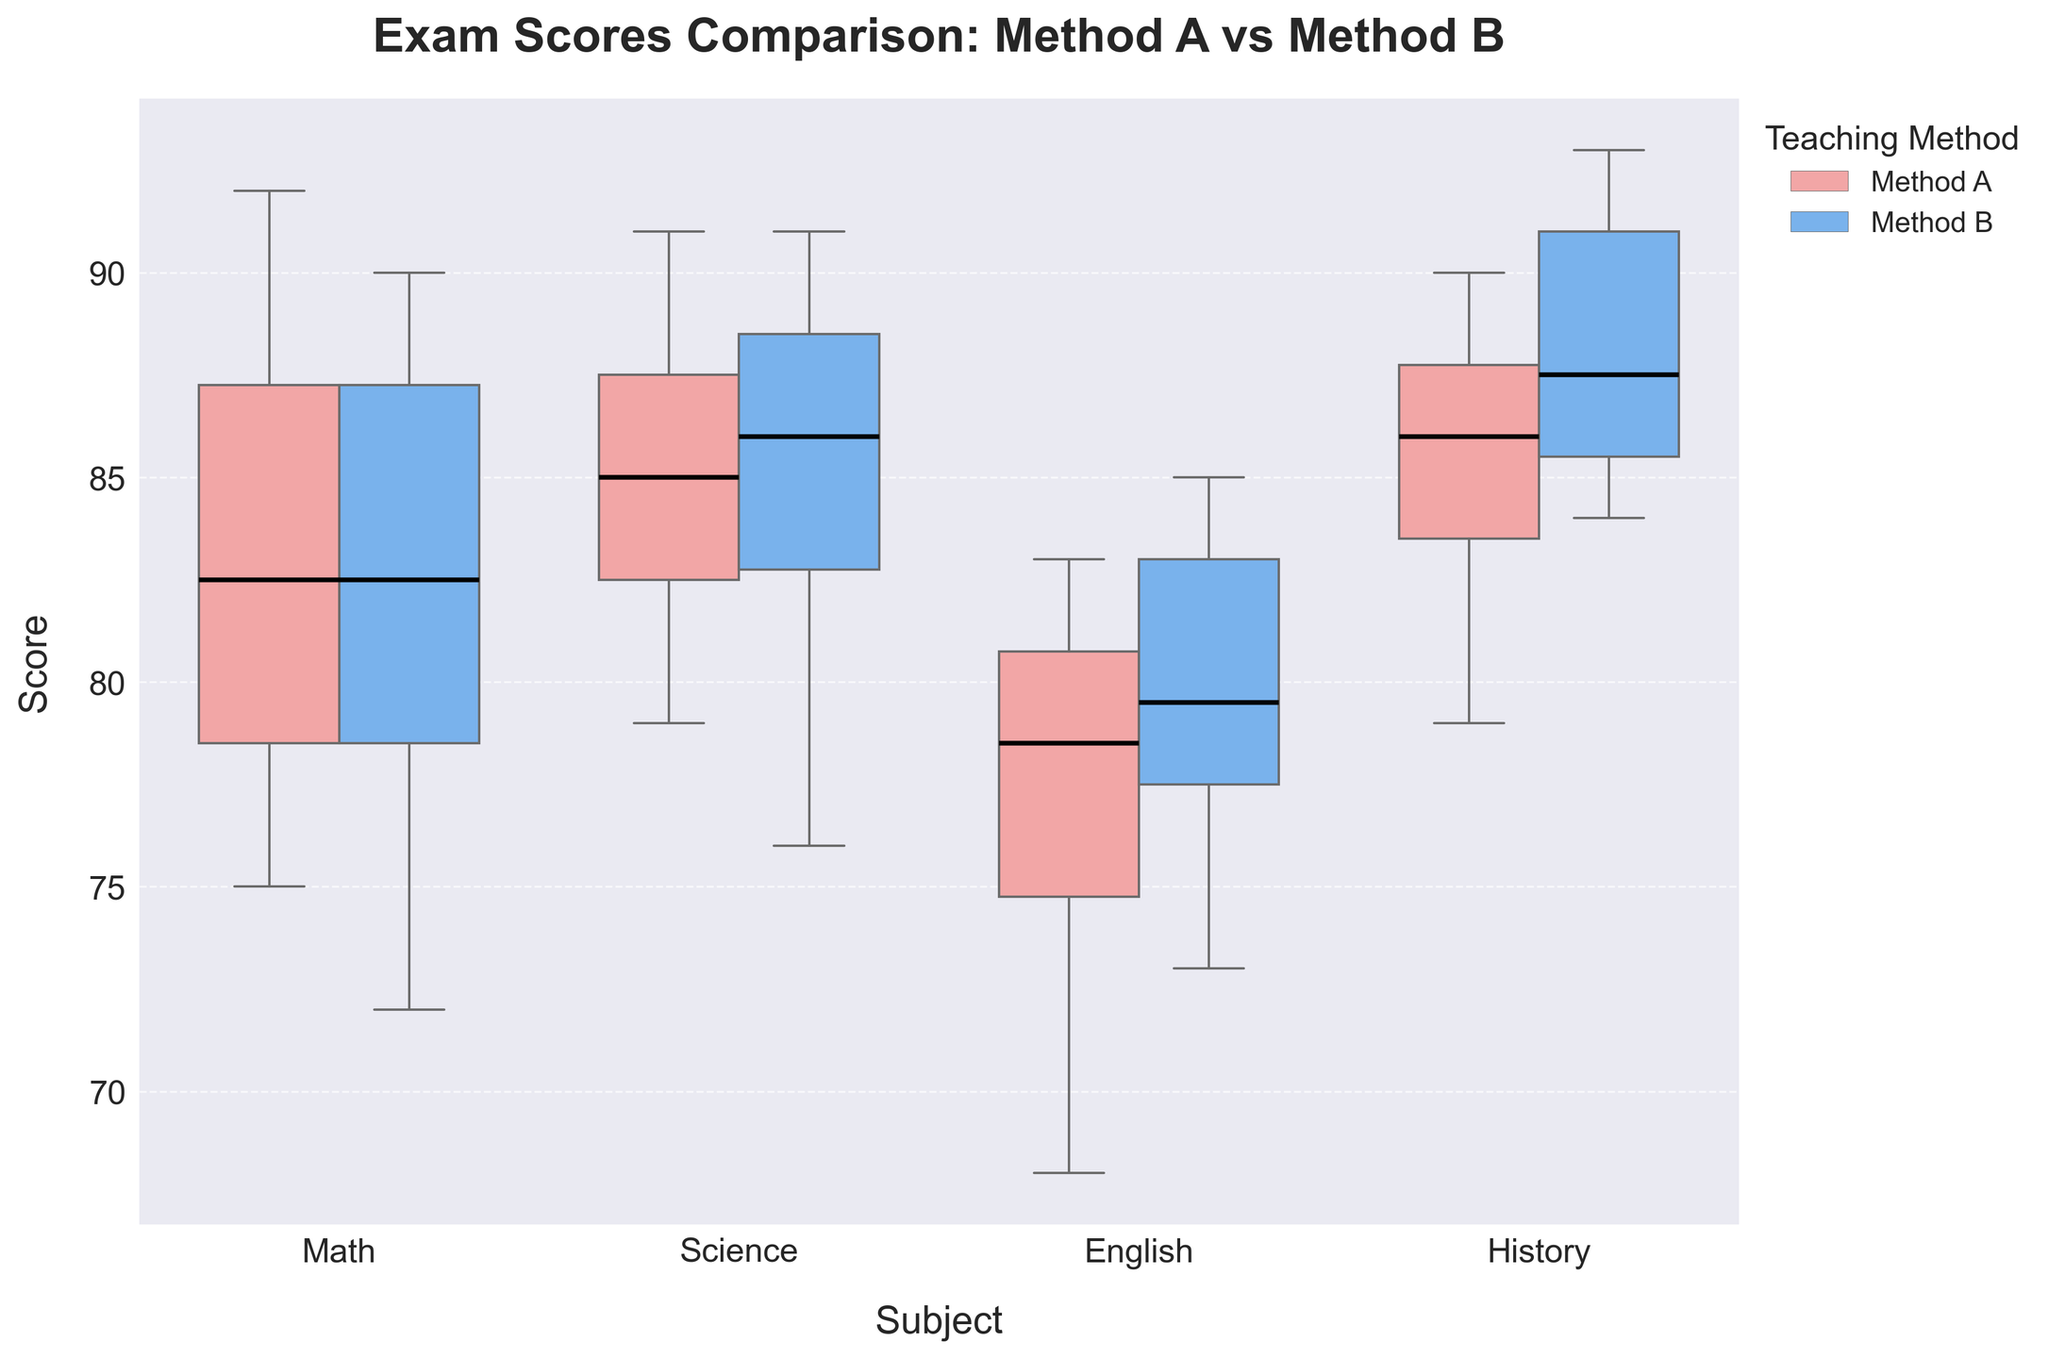What is the title of the plot? The title is usually positioned at the top of the plot and provides a summary of the visual information. In this case, it is located above the box plots.
Answer: Exam Scores Comparison: Method A vs Method B Which subject has the lowest median score for Method A? To determine the lowest median score, look at the line inside the box for Method A in each subject. Compare the positions of these lines vertically across all subjects.
Answer: English What is the median score for Method B in Science? Median scores are represented by the black line inside the box. For Science under Method B, find the position of the line within the Science section.
Answer: 87 Among the subjects, which one shows the largest interquartile range (IQR) for Method A? To identify the largest IQR, compare the lengths of the boxes for Method A across all subjects. The IQR is the distance between the top and bottom of each box.
Answer: Math Which method has higher scores in History and what is the median score for that method? Analyze the median lines within the History section for both methods. Look for the higher median score.
Answer: Method B, 88 How does the median score of Method B in Math compare to the median score of Method A in Math? Compare the black horizontal lines inside the boxes for Math between Method A and Method B.
Answer: Method B is higher What subject shows the least difference in median scores between Method A and Method B? Calculate the median difference for each subject by comparing the line inside each box for Method A and Method B. Find the smallest difference.
Answer: History Which method shows greater variability in Science scores and by what visible indication can you tell? Variability can be determined by the size of the box and the range of the whiskers. Compare these elements for Science between Method A and Method B.
Answer: Method A, larger whiskers and box What can be inferred about the flier markers in this plot? Flier markers represent outliers. Observe their shapes and dispersion outside the boxes across different subjects and methods.
Answer: They are marked with diamonds and are few In which subject do both methods have the closest median scores, and what are those scores? Compare the median lines within each subject to see where Method A and Method B are closest.
Answer: History, both near 88 